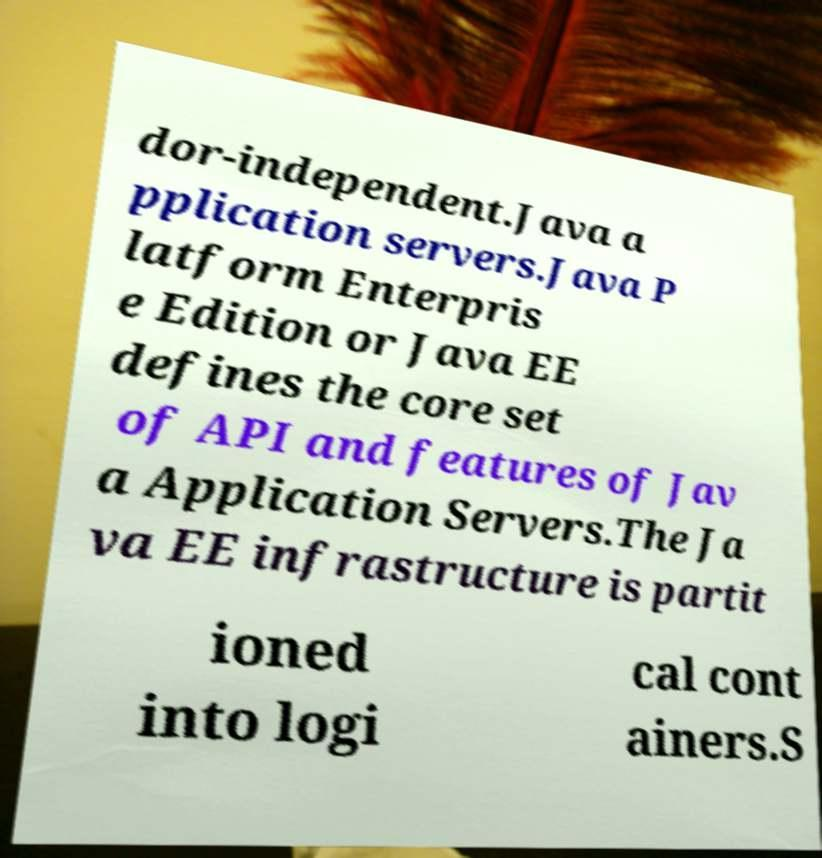For documentation purposes, I need the text within this image transcribed. Could you provide that? dor-independent.Java a pplication servers.Java P latform Enterpris e Edition or Java EE defines the core set of API and features of Jav a Application Servers.The Ja va EE infrastructure is partit ioned into logi cal cont ainers.S 